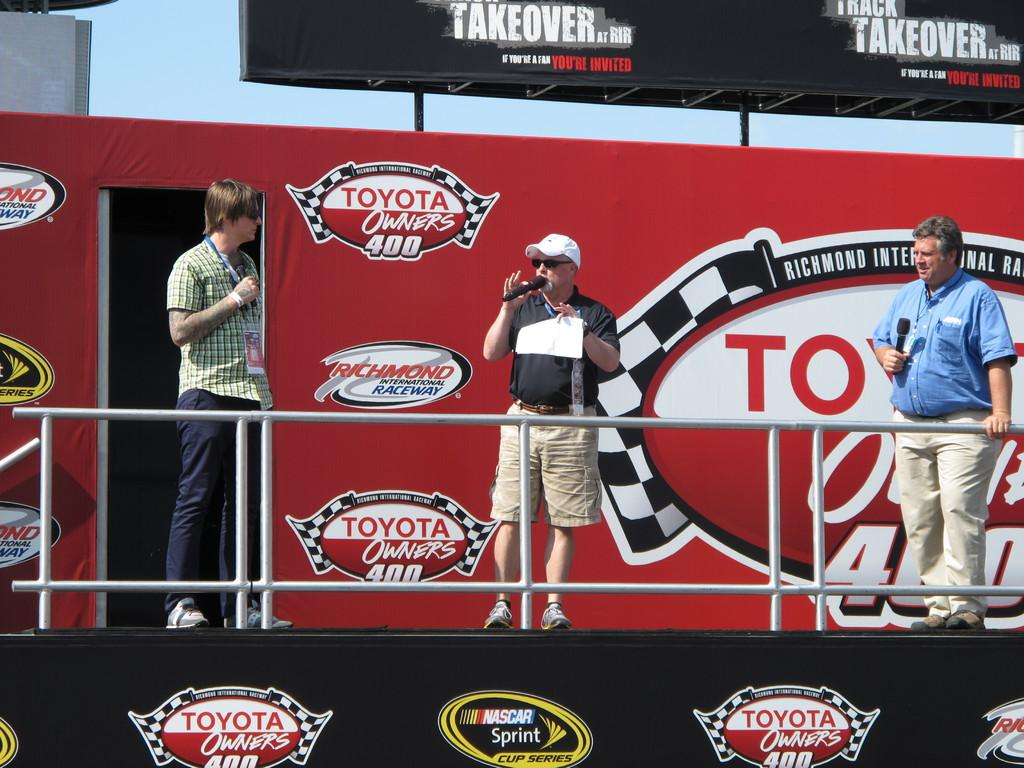<image>
Provide a brief description of the given image. Men giving a speech in front of a wall which says Toyota Owners. 